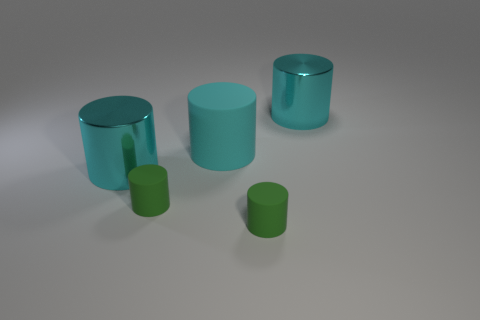What number of other cylinders have the same color as the big matte cylinder?
Your response must be concise. 2. The cyan matte cylinder has what size?
Give a very brief answer. Large. What is the color of the cylinder that is to the right of the big matte cylinder and in front of the big rubber cylinder?
Your answer should be very brief. Green. How many tiny purple metal cubes are there?
Provide a short and direct response. 0. There is a cyan rubber thing; does it have the same size as the green cylinder on the right side of the big cyan rubber cylinder?
Offer a terse response. No. What material is the small green thing in front of the small cylinder that is left of the cyan rubber cylinder?
Your answer should be very brief. Rubber. How big is the metal cylinder on the right side of the cyan shiny cylinder on the left side of the large object to the right of the cyan matte cylinder?
Your response must be concise. Large. Is the shape of the big rubber thing the same as the rubber object on the right side of the big cyan matte object?
Offer a very short reply. Yes. How many matte objects are either cyan cylinders or small yellow balls?
Provide a short and direct response. 1. Is there a large cyan thing that is to the left of the large rubber thing that is on the right side of the small rubber object to the left of the cyan matte cylinder?
Your response must be concise. Yes. 